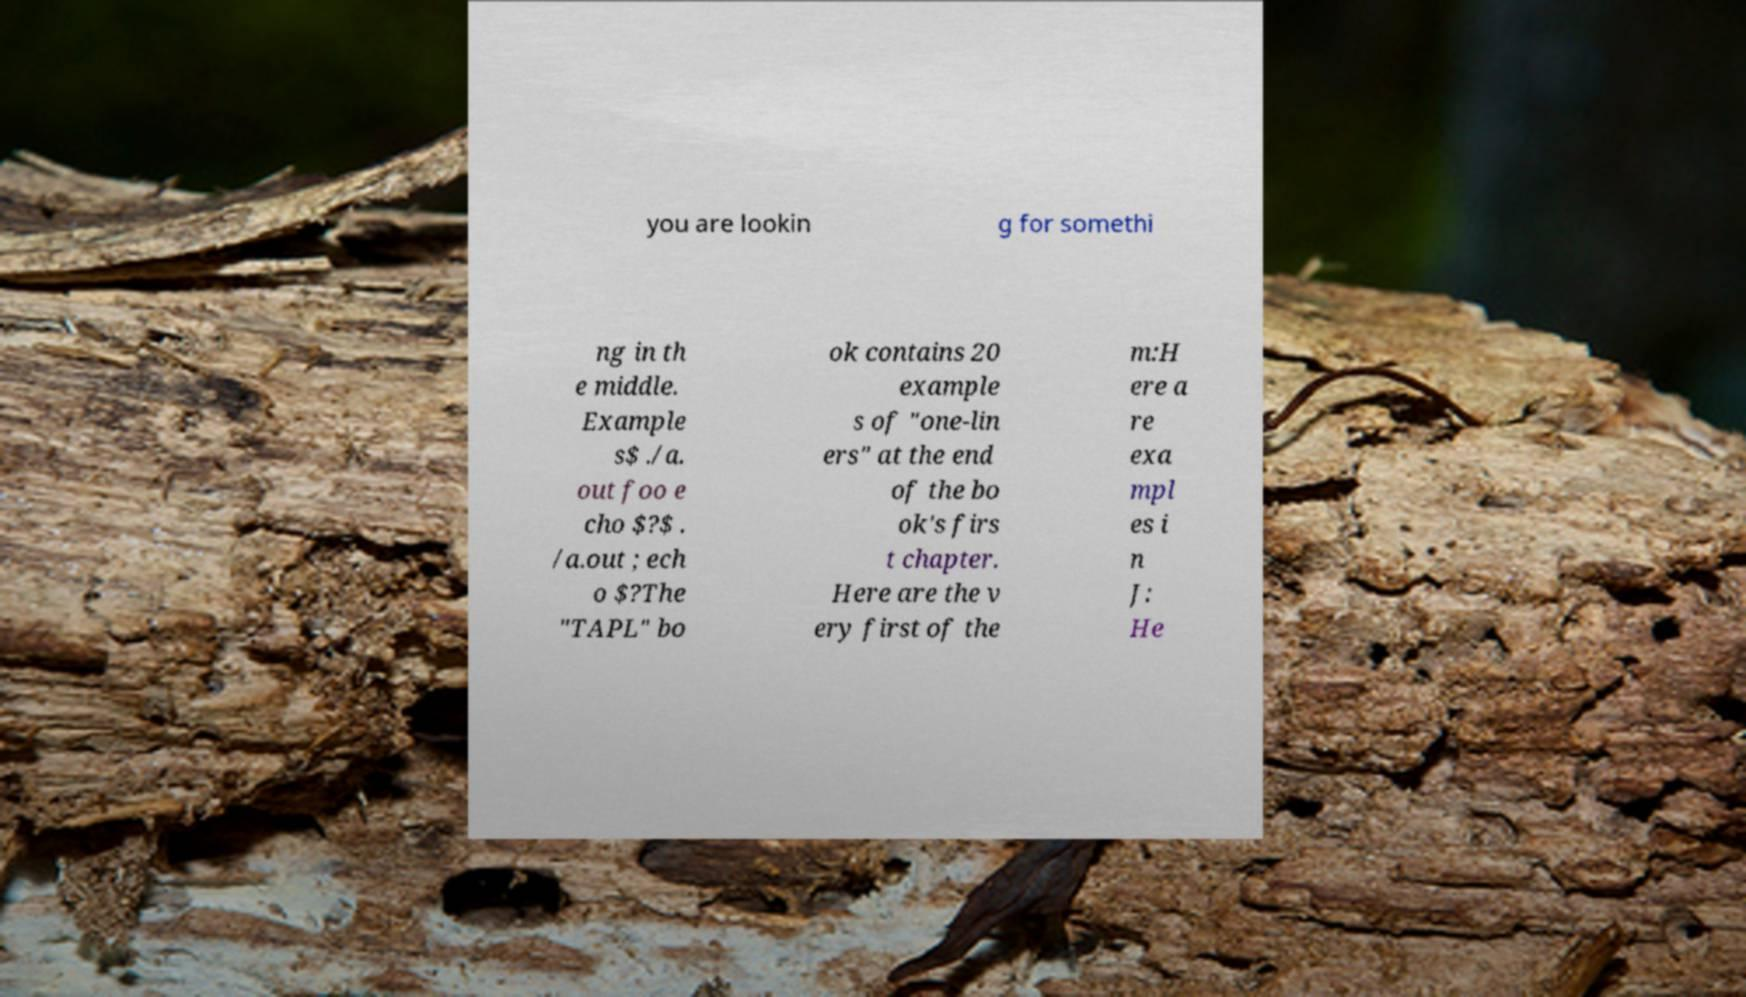Please identify and transcribe the text found in this image. you are lookin g for somethi ng in th e middle. Example s$ ./a. out foo e cho $?$ . /a.out ; ech o $?The "TAPL" bo ok contains 20 example s of "one-lin ers" at the end of the bo ok's firs t chapter. Here are the v ery first of the m:H ere a re exa mpl es i n J: He 